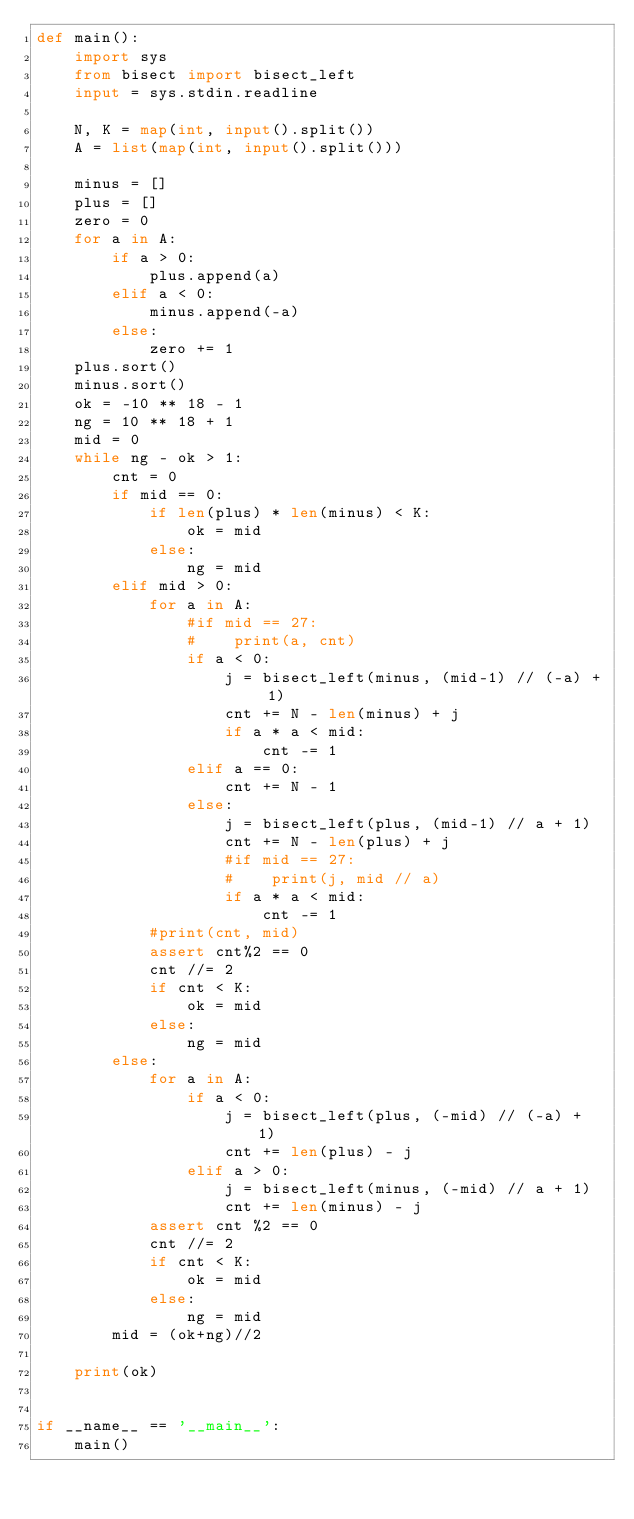Convert code to text. <code><loc_0><loc_0><loc_500><loc_500><_Python_>def main():
    import sys
    from bisect import bisect_left
    input = sys.stdin.readline

    N, K = map(int, input().split())
    A = list(map(int, input().split()))

    minus = []
    plus = []
    zero = 0
    for a in A:
        if a > 0:
            plus.append(a)
        elif a < 0:
            minus.append(-a)
        else:
            zero += 1
    plus.sort()
    minus.sort()
    ok = -10 ** 18 - 1
    ng = 10 ** 18 + 1
    mid = 0
    while ng - ok > 1:
        cnt = 0
        if mid == 0:
            if len(plus) * len(minus) < K:
                ok = mid
            else:
                ng = mid
        elif mid > 0:
            for a in A:
                #if mid == 27:
                #    print(a, cnt)
                if a < 0:
                    j = bisect_left(minus, (mid-1) // (-a) + 1)
                    cnt += N - len(minus) + j
                    if a * a < mid:
                        cnt -= 1
                elif a == 0:
                    cnt += N - 1
                else:
                    j = bisect_left(plus, (mid-1) // a + 1)
                    cnt += N - len(plus) + j
                    #if mid == 27:
                    #    print(j, mid // a)
                    if a * a < mid:
                        cnt -= 1
            #print(cnt, mid)
            assert cnt%2 == 0
            cnt //= 2
            if cnt < K:
                ok = mid
            else:
                ng = mid
        else:
            for a in A:
                if a < 0:
                    j = bisect_left(plus, (-mid) // (-a) + 1)
                    cnt += len(plus) - j
                elif a > 0:
                    j = bisect_left(minus, (-mid) // a + 1)
                    cnt += len(minus) - j
            assert cnt %2 == 0
            cnt //= 2
            if cnt < K:
                ok = mid
            else:
                ng = mid
        mid = (ok+ng)//2

    print(ok)


if __name__ == '__main__':
    main()
</code> 